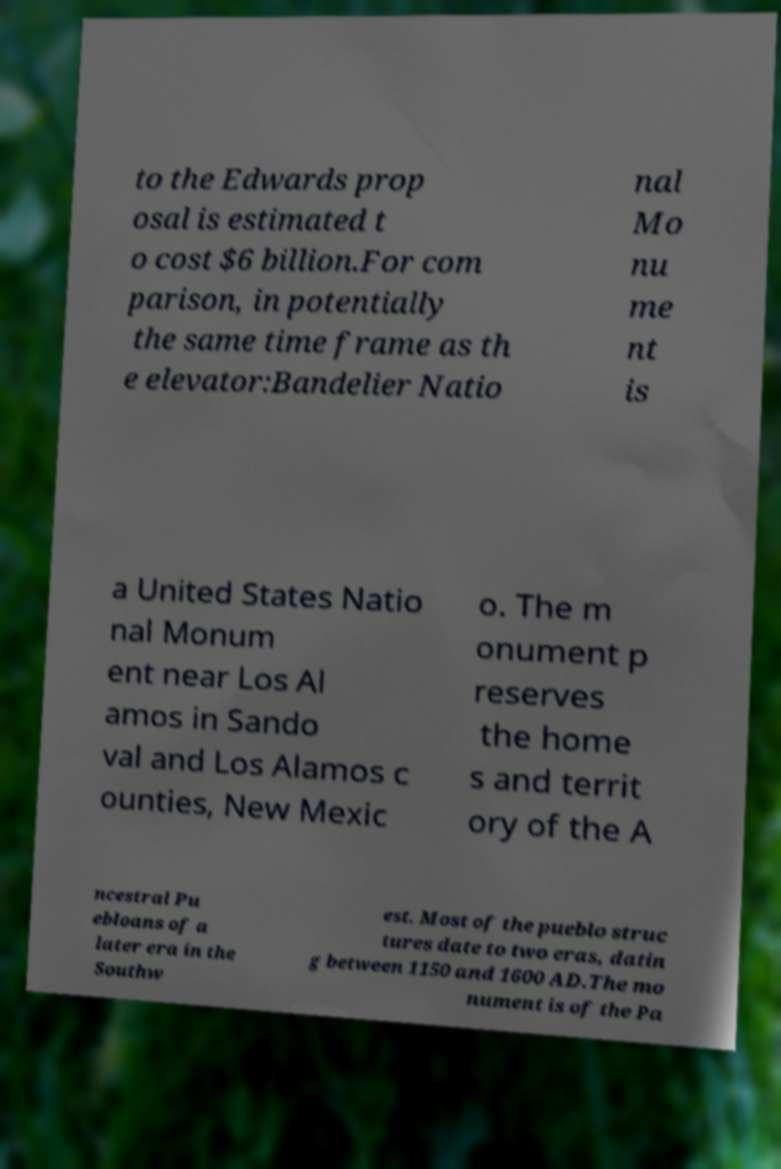What messages or text are displayed in this image? I need them in a readable, typed format. to the Edwards prop osal is estimated t o cost $6 billion.For com parison, in potentially the same time frame as th e elevator:Bandelier Natio nal Mo nu me nt is a United States Natio nal Monum ent near Los Al amos in Sando val and Los Alamos c ounties, New Mexic o. The m onument p reserves the home s and territ ory of the A ncestral Pu ebloans of a later era in the Southw est. Most of the pueblo struc tures date to two eras, datin g between 1150 and 1600 AD.The mo nument is of the Pa 